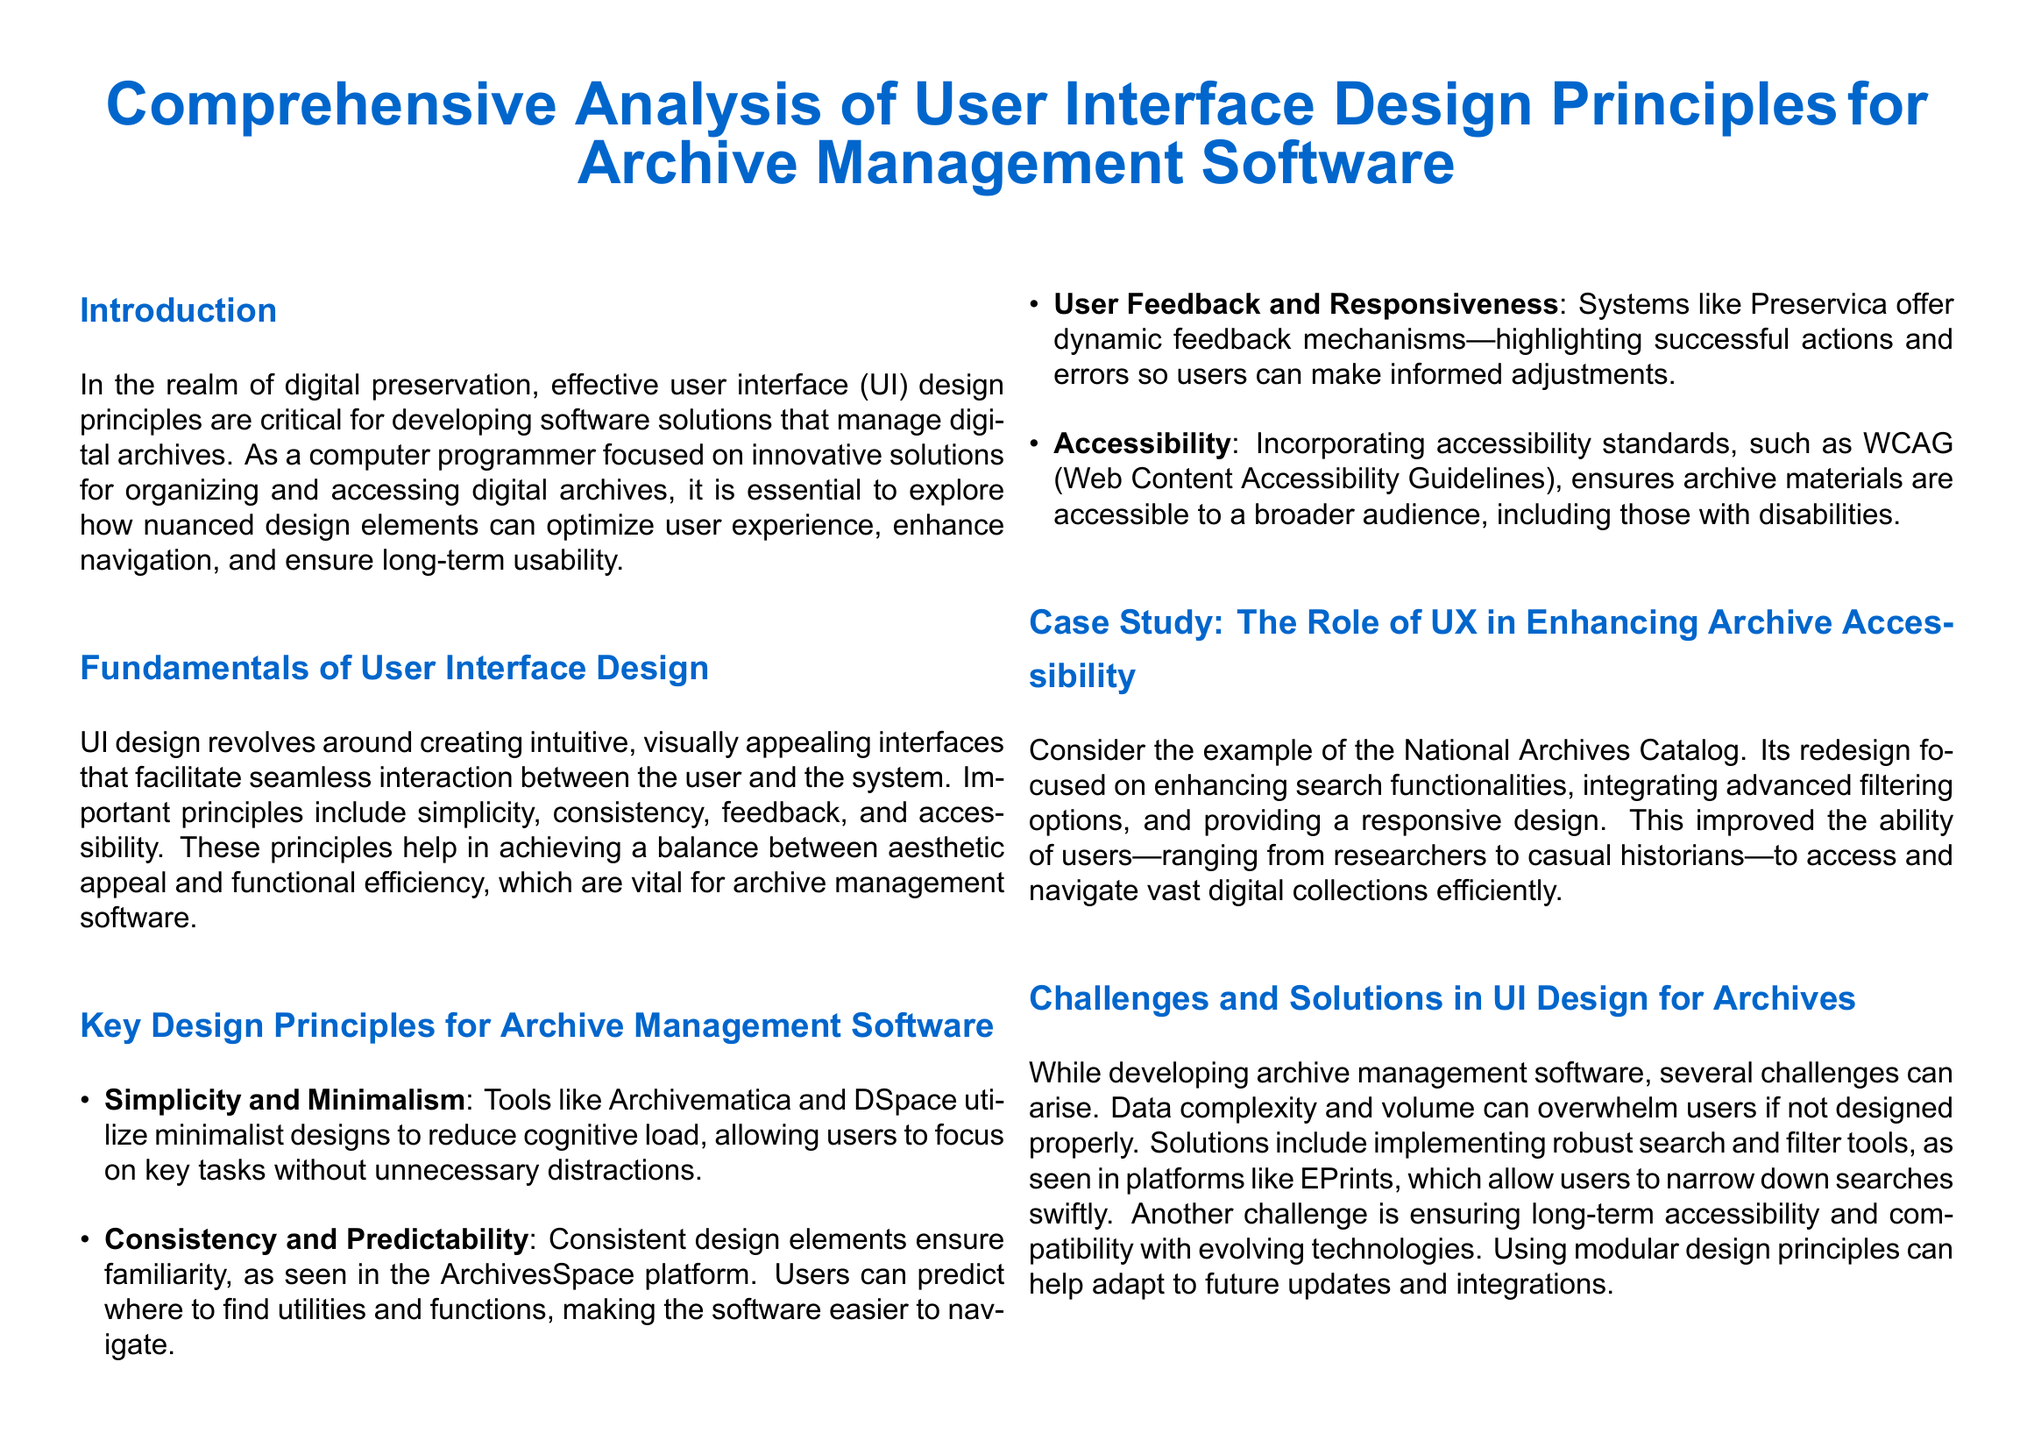what is the title of the document? The title of the document is displayed prominently at the beginning, highlighting its focus on specific UI design principles for a particular software context.
Answer: Comprehensive Analysis of User Interface Design Principles for Archive Management Software which software is mentioned for minimalist designs? The document refers to specific software that exemplifies minimalist designs which are helpful for reducing cognitive load for users.
Answer: Archivematica what principle ensures familiarity in UI design? The document outlines a key principle that guarantees users can easily predict where to find utilities and functions, resulting in an easier navigation experience.
Answer: Consistency what accessibility standards are referenced? The document mentions specific guidelines aimed at making archive materials accessible to a broader audience, including individuals with disabilities.
Answer: WCAG which platform exemplifies dynamic feedback mechanisms? The document describes a particular software that uses feedback mechanisms to inform users about successful actions and errors for better user decision-making.
Answer: Preservica what is a major challenge mentioned in UI design for archives? The document identifies a significant issue that can hinder user experience, particularly when managing complex datasets within archive management software.
Answer: Data complexity what enhanced feature was included in the National Archives Catalog redesign? The document points out an improvement that focused on user interaction, particularly enhancing search capabilities within the archive system.
Answer: Advanced filtering options what design principle is emphasized for the success of archive management software? The document concludes with specific principles critical to creating effective user-friendly interfaces for archivists and researchers leveraging archive management software.
Answer: Simplicity 